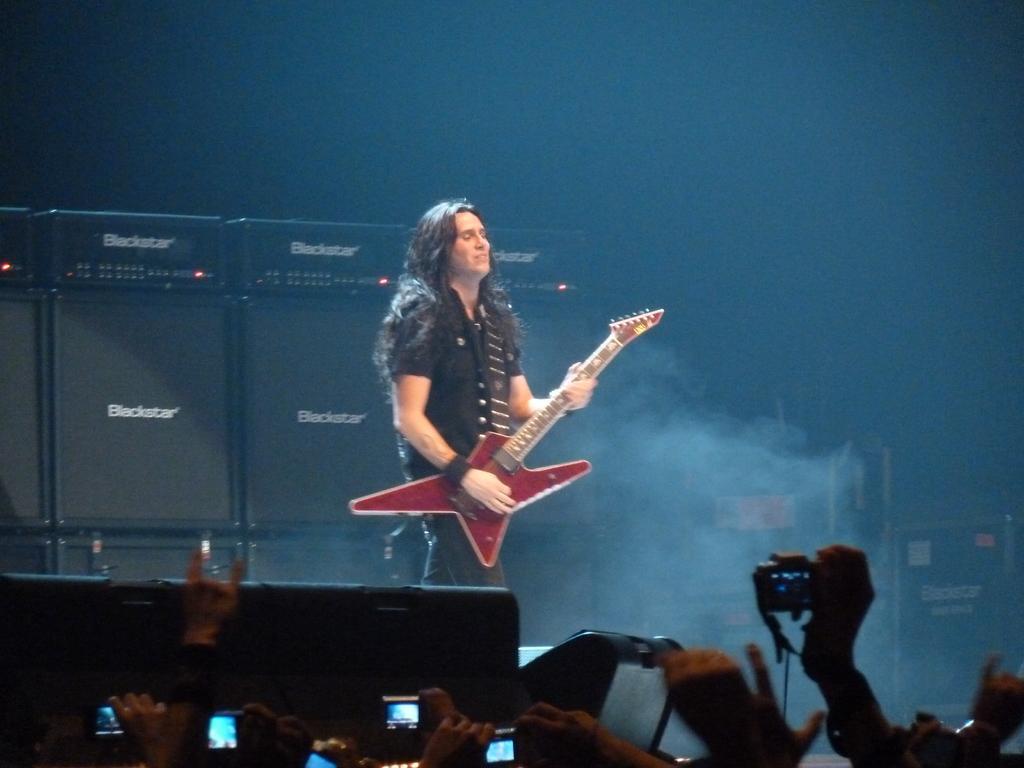How would you summarize this image in a sentence or two? In this image we can see a man standing on the floor and playing the guitar, and in front here a group of people are standing and holding the camera in the hand. 